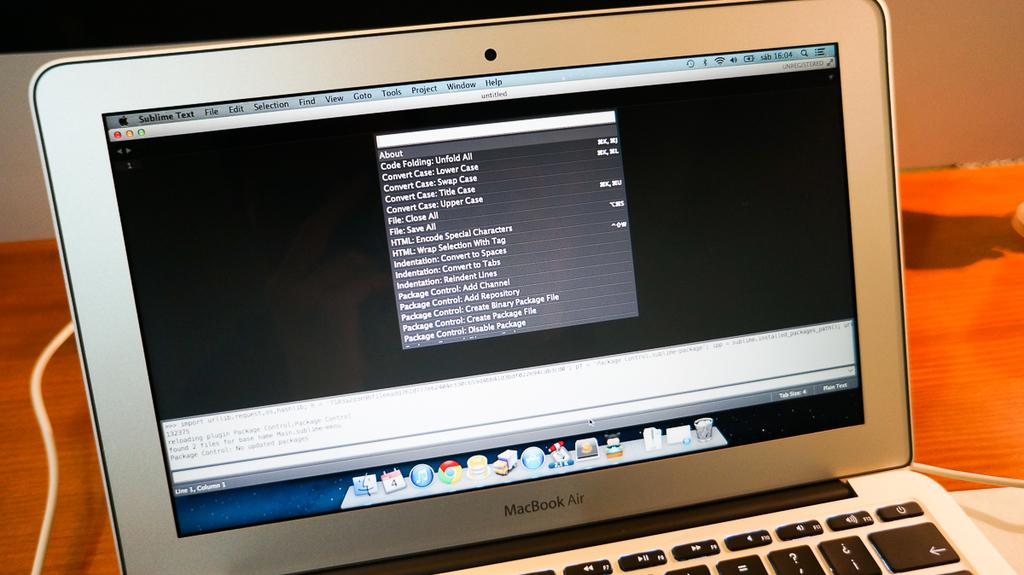<image>
Provide a brief description of the given image. macbook air laptop in silver is turned on and on  the desk 